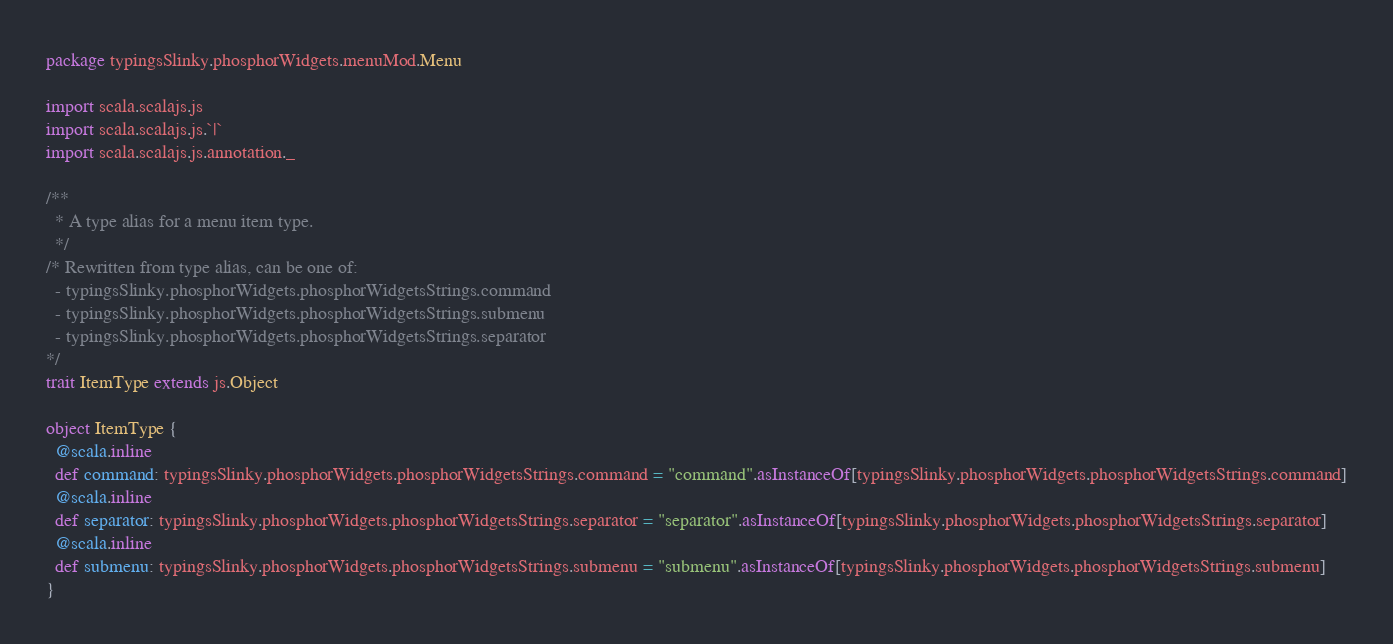Convert code to text. <code><loc_0><loc_0><loc_500><loc_500><_Scala_>package typingsSlinky.phosphorWidgets.menuMod.Menu

import scala.scalajs.js
import scala.scalajs.js.`|`
import scala.scalajs.js.annotation._

/**
  * A type alias for a menu item type.
  */
/* Rewritten from type alias, can be one of: 
  - typingsSlinky.phosphorWidgets.phosphorWidgetsStrings.command
  - typingsSlinky.phosphorWidgets.phosphorWidgetsStrings.submenu
  - typingsSlinky.phosphorWidgets.phosphorWidgetsStrings.separator
*/
trait ItemType extends js.Object

object ItemType {
  @scala.inline
  def command: typingsSlinky.phosphorWidgets.phosphorWidgetsStrings.command = "command".asInstanceOf[typingsSlinky.phosphorWidgets.phosphorWidgetsStrings.command]
  @scala.inline
  def separator: typingsSlinky.phosphorWidgets.phosphorWidgetsStrings.separator = "separator".asInstanceOf[typingsSlinky.phosphorWidgets.phosphorWidgetsStrings.separator]
  @scala.inline
  def submenu: typingsSlinky.phosphorWidgets.phosphorWidgetsStrings.submenu = "submenu".asInstanceOf[typingsSlinky.phosphorWidgets.phosphorWidgetsStrings.submenu]
}

</code> 